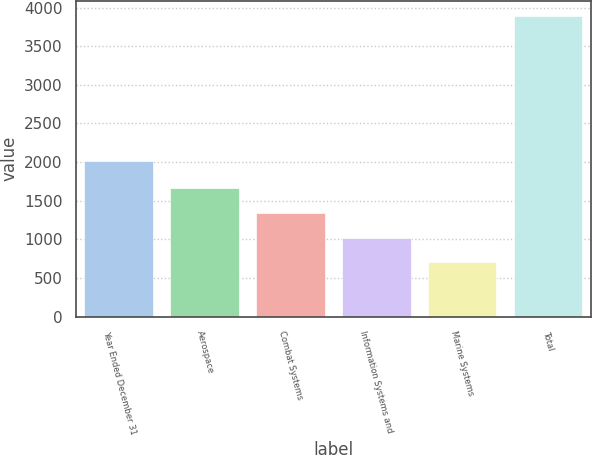<chart> <loc_0><loc_0><loc_500><loc_500><bar_chart><fcel>Year Ended December 31<fcel>Aerospace<fcel>Combat Systems<fcel>Information Systems and<fcel>Marine Systems<fcel>Total<nl><fcel>2014<fcel>1658.8<fcel>1340.2<fcel>1021.6<fcel>703<fcel>3889<nl></chart> 